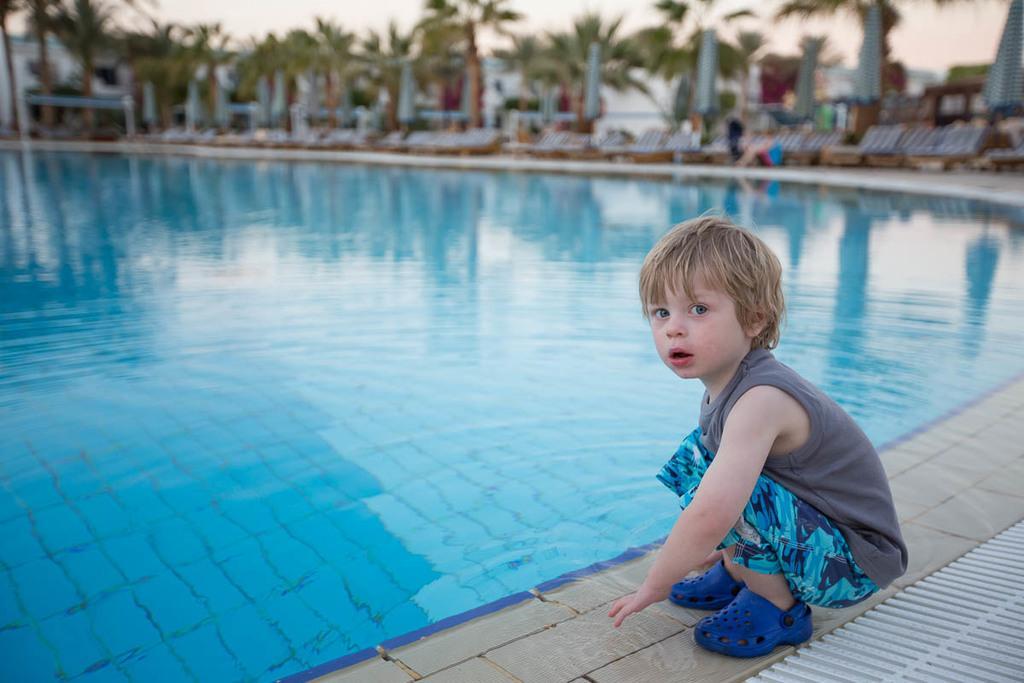Could you give a brief overview of what you see in this image? A boy is sitting in squat position. There is a pool. There are beach chairs and trees at the back. 